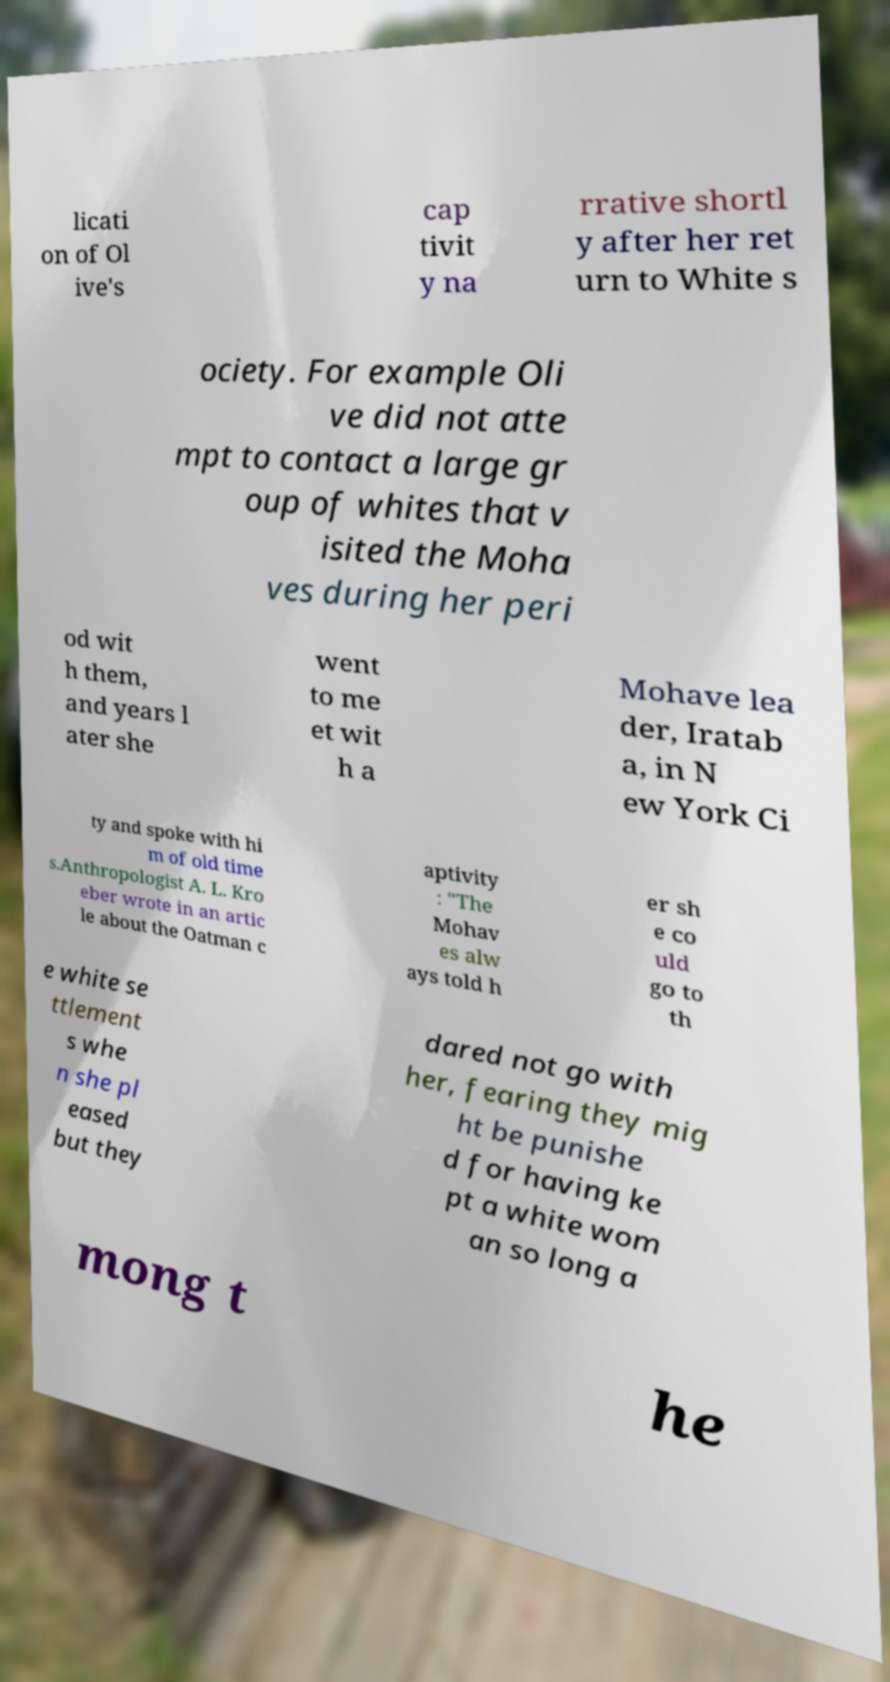For documentation purposes, I need the text within this image transcribed. Could you provide that? licati on of Ol ive's cap tivit y na rrative shortl y after her ret urn to White s ociety. For example Oli ve did not atte mpt to contact a large gr oup of whites that v isited the Moha ves during her peri od wit h them, and years l ater she went to me et wit h a Mohave lea der, Iratab a, in N ew York Ci ty and spoke with hi m of old time s.Anthropologist A. L. Kro eber wrote in an artic le about the Oatman c aptivity : "The Mohav es alw ays told h er sh e co uld go to th e white se ttlement s whe n she pl eased but they dared not go with her, fearing they mig ht be punishe d for having ke pt a white wom an so long a mong t he 